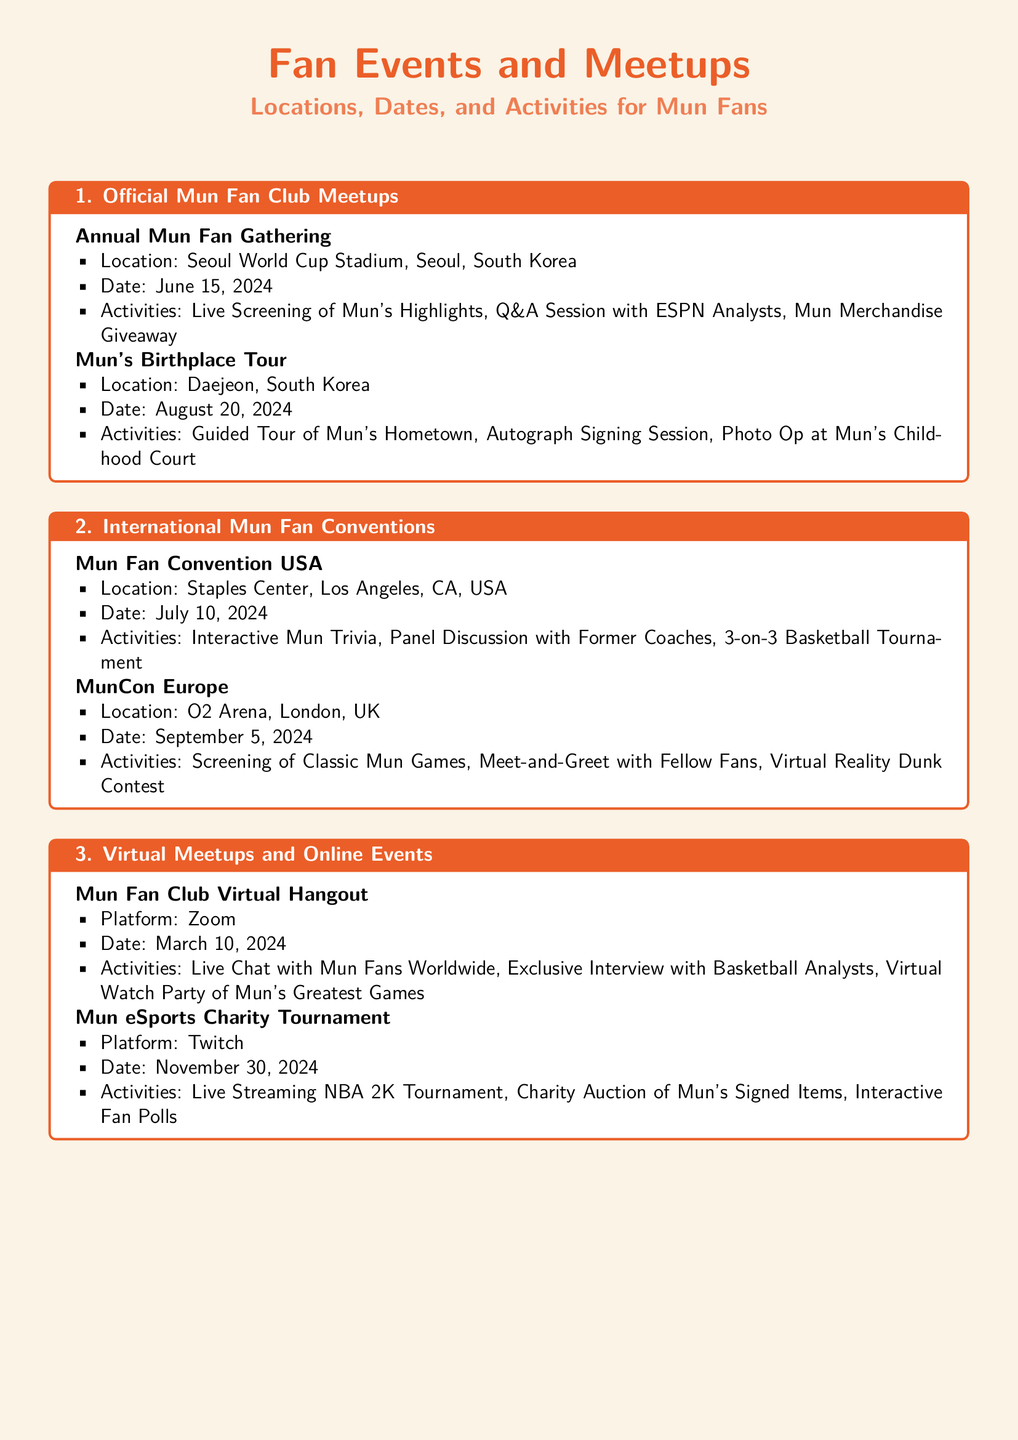What is the location of the Annual Mun Fan Gathering? The location is specified in the document, which states that the Annual Mun Fan Gathering will be held at Seoul World Cup Stadium in Seoul, South Korea.
Answer: Seoul World Cup Stadium, Seoul, South Korea When is the Mun Fan Convention USA scheduled? The date for the Mun Fan Convention USA is indicated in the document, which mentions July 10, 2024.
Answer: July 10, 2024 What activity is planned for the Mun's Birthplace Tour? Activities listed in the document for Mun's Birthplace Tour include a Guided Tour of Mun's Hometown.
Answer: Guided Tour of Mun's Hometown What platform will be used for the Mun Fan Club Virtual Hangout? The document specifies that the platform for this event will be Zoom.
Answer: Zoom How many activities are mentioned for the Mun's Basketball Clinic? The document lists three distinct activities, therefore, the number of activities is three.
Answer: Three What is the date of the eSports Charity Tournament? The document provides the date for the eSports Charity Tournament, which is November 30, 2024.
Answer: November 30, 2024 Where will the Book Signing: 'Mun's Journey' take place? The document indicates that it will be held at the Kyobo Book Centre in Gangnam, Seoul, South Korea.
Answer: Kyobo Book Centre, Gangnam, Seoul, South Korea Which event includes a 3-on-3 Basketball Tournament? According to the document, the event that includes this tournament is the Mun Fan Convention USA.
Answer: Mun Fan Convention USA 